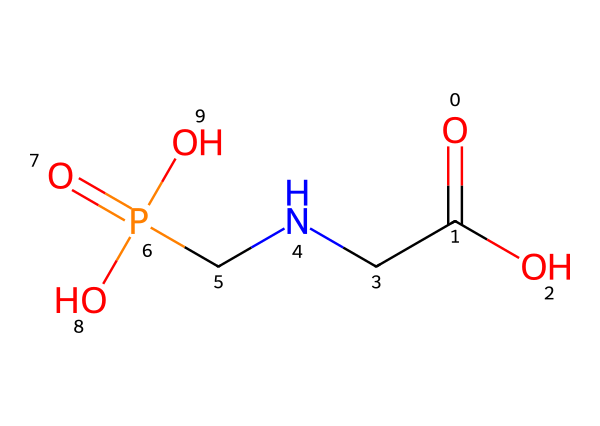What is the molecular formula of glyphosate? The SMILES representation indicates the atoms present. The breakdown reveals carbon, hydrogen, nitrogen, phosphorus, and oxygen atoms, leading to the formula C3H8N5O5P.
Answer: C3H8N5O5P How many carbon atoms are in glyphosate? In the provided SMILES, 'C' represents carbon. Counting the 'C's gives three carbon atoms.
Answer: 3 What type of chemical compound is glyphosate? Glyphosate is classified as an amine due to the presence of the nitrogen atom in an amine arrangement and an acid due to its carboxylic acid group.
Answer: amine Which groups contribute to glyphosate's acidity? The chemical contains a carboxylic acid group represented by -COOH in the structure, indicating the acidic property.
Answer: carboxylic acid How many nitrogen atoms are in glyphosate? The SMILES shows two 'N' atoms, indicating the presence of two nitrogen atoms in the glyphosate structure.
Answer: 2 What functional groups are present in glyphosate? Analyzing the structure shows a carboxylic acid group, an amine group, and a phosphonic acid group, which are key functional groups in glyphosate.
Answer: carboxylic acid, amine, phosphonic acid What symmetry can be observed in the glyphosate structure? The arrangement of atoms shows a geometric symmetry due to the balanced distribution of atoms around the central nitrogen and phosphorus atoms, leading to a symmetrical shape.
Answer: geometric symmetry 